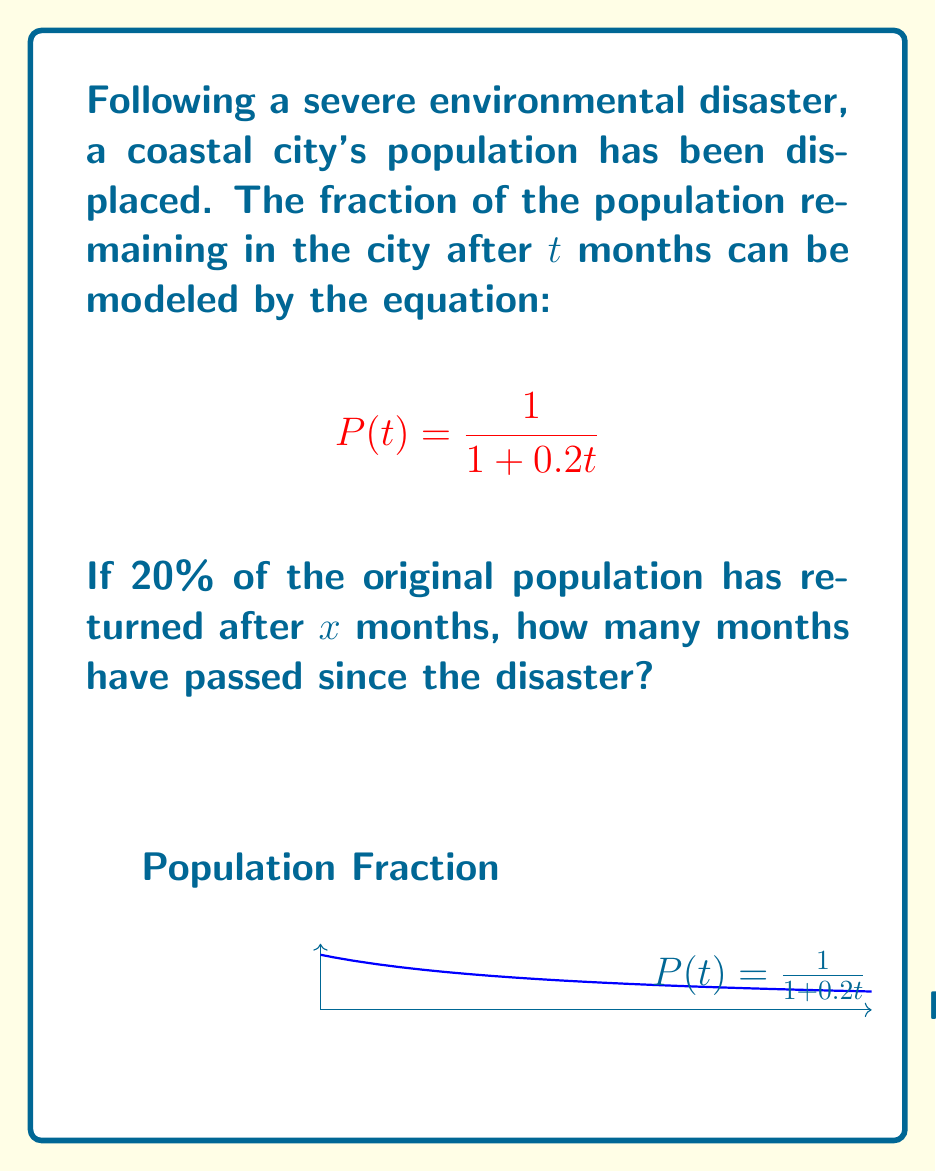Provide a solution to this math problem. Let's approach this step-by-step:

1) We know that after x months, 20% of the original population has returned. This means that the fraction of the population remaining is 1.2 times the original fraction. We can express this as:

   $$P(x) = 1.2 \cdot \frac{1}{1 + 0.2x}$$

2) We can set up an equation:

   $$1.2 \cdot \frac{1}{1 + 0.2x} = \frac{1}{1 + 0.2x}$$

3) Simplify the left side:

   $$\frac{1.2}{1 + 0.2x} = \frac{1}{1 + 0.2x}$$

4) Cross multiply:

   $$1.2(1 + 0.2x) = 1$$

5) Distribute on the left side:

   $$1.2 + 0.24x = 1$$

6) Subtract 1.2 from both sides:

   $$0.24x = -0.2$$

7) Divide both sides by 0.24:

   $$x = -\frac{0.2}{0.24} = -\frac{5}{6}$$

8) Since time cannot be negative in this context, we take the absolute value:

   $$x = \frac{5}{6} \approx 0.833$$

Therefore, approximately 0.833 months, or about 25 days, have passed since the disaster.
Answer: $\frac{5}{6}$ months 